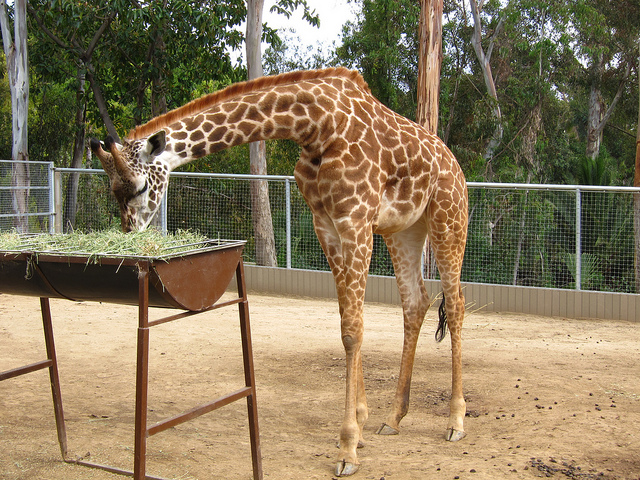How many zoo creatures? There is one giraffe visible in the image, gracefully bending down to feed from a metal trough filled with hay. 